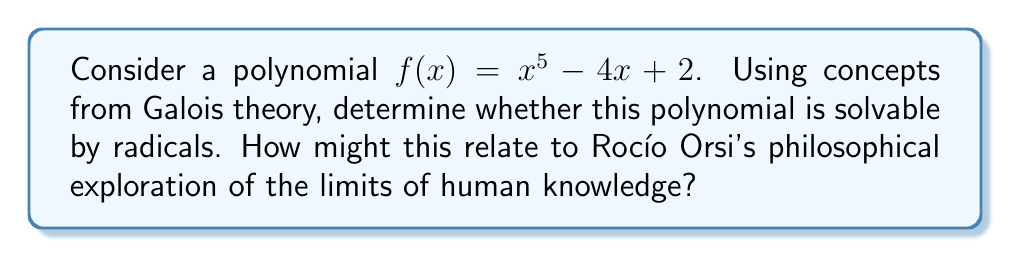Give your solution to this math problem. To determine if the polynomial $f(x) = x^5 - 4x + 2$ is solvable by radicals, we'll follow these steps:

1) First, we need to determine if the polynomial is irreducible over $\mathbb{Q}$. We can use Eisenstein's criterion with the prime $p=2$:
   - The leading coefficient is not divisible by 2
   - All other coefficients are divisible by 2
   - The constant term (2) is not divisible by $2^2 = 4$
   Therefore, $f(x)$ is irreducible over $\mathbb{Q}$.

2) Now, we need to find the Galois group of $f(x)$. Since $f(x)$ is a quintic polynomial, its Galois group is a subgroup of $S_5$ (the symmetric group on 5 elements).

3) To determine the exact Galois group, we need to factor $f(x)$ modulo various primes and observe the cycle structure:
   - mod 2: $f(x) \equiv x^5 + 1 \equiv (x+1)^5$ (one 5-cycle)
   - mod 3: $f(x) \equiv x^5 + 2x + 2 \equiv (x+1)(x^4+2x^3+2x^2+2x+2)$ (one 1-cycle, one 4-cycle)
   - mod 5: $f(x) \equiv x^5 + x + 2$ (one 5-cycle)

4) The presence of both a 5-cycle and a 4-cycle in the factorization patterns indicates that the Galois group must be the full symmetric group $S_5$.

5) According to Galois theory, a polynomial is solvable by radicals if and only if its Galois group is a solvable group.

6) $S_5$ is not a solvable group (it's the smallest non-solvable symmetric group).

7) Therefore, $f(x)$ is not solvable by radicals.

This result connects to Rocío Orsi's philosophical work on the limits of human knowledge. Just as there are polynomials whose solutions cannot be expressed using radicals, there may be philosophical questions or aspects of reality that are inherently beyond human comprehension or expression within our current frameworks of understanding.
Answer: Not solvable by radicals 